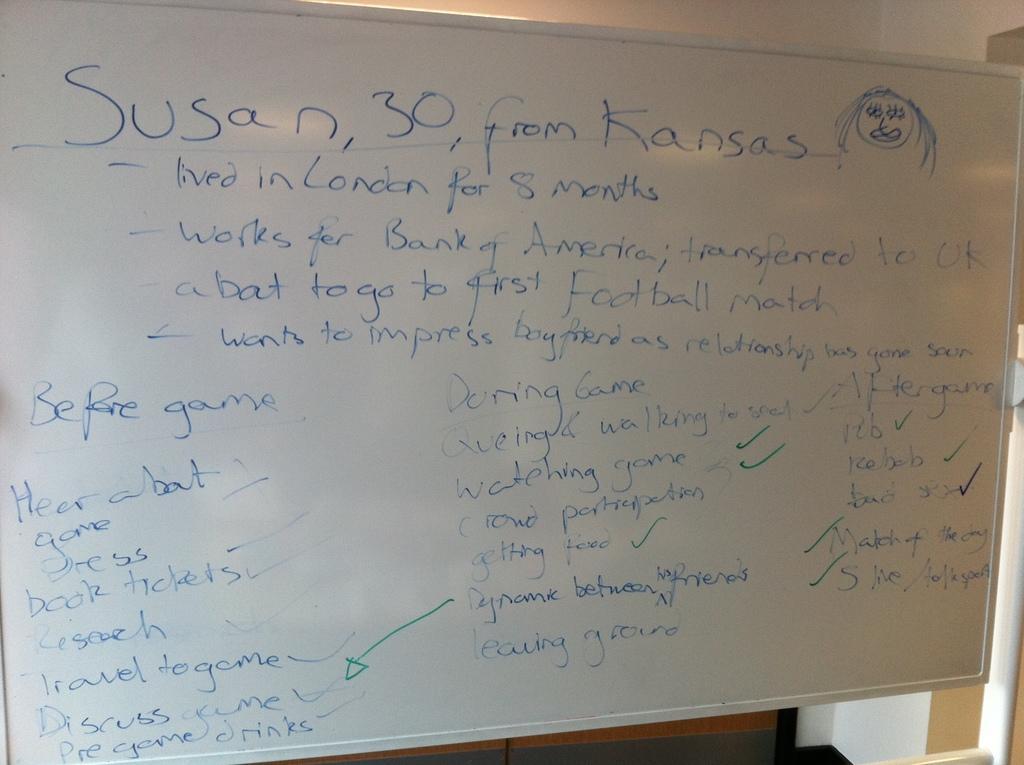Can you describe this image briefly? In this image, we can see a board contains some written text. 